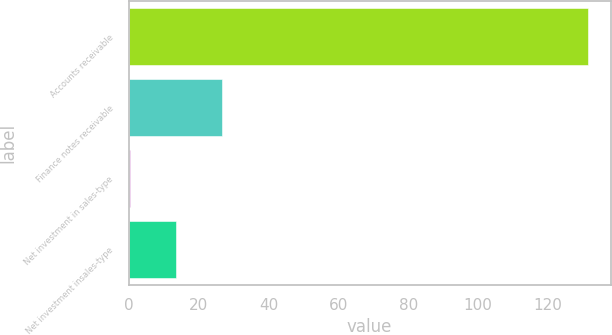Convert chart to OTSL. <chart><loc_0><loc_0><loc_500><loc_500><bar_chart><fcel>Accounts receivable<fcel>Finance notes receivable<fcel>Net investment in sales-type<fcel>Net investment insales-type<nl><fcel>131.4<fcel>26.6<fcel>0.4<fcel>13.5<nl></chart> 